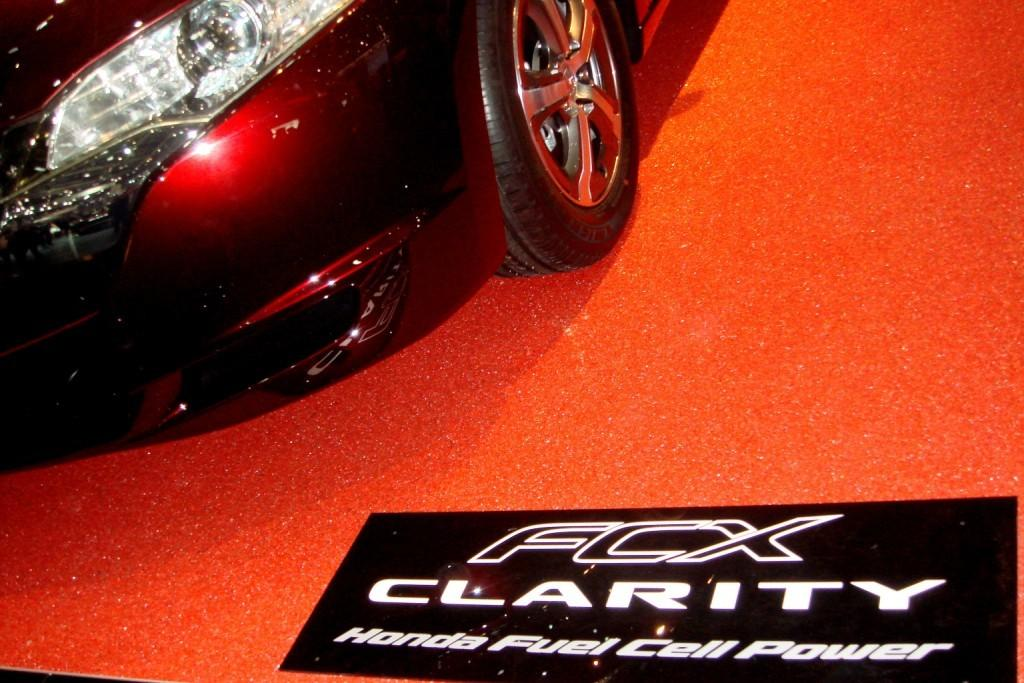What type of vehicle is in the image? There is a car in the image. What color is the car? The car is maroon in color. What are the car's wheels used for? The car's wheels are used for mobility. What are the car's headlights used for? The car's headlights are used for illumination during low light conditions. What is the board placed on in the image? The board is placed on a red carpet. How many oranges are hanging from the car's bumper in the image? There are no oranges present in the image, and therefore none are hanging from the car's bumper. 